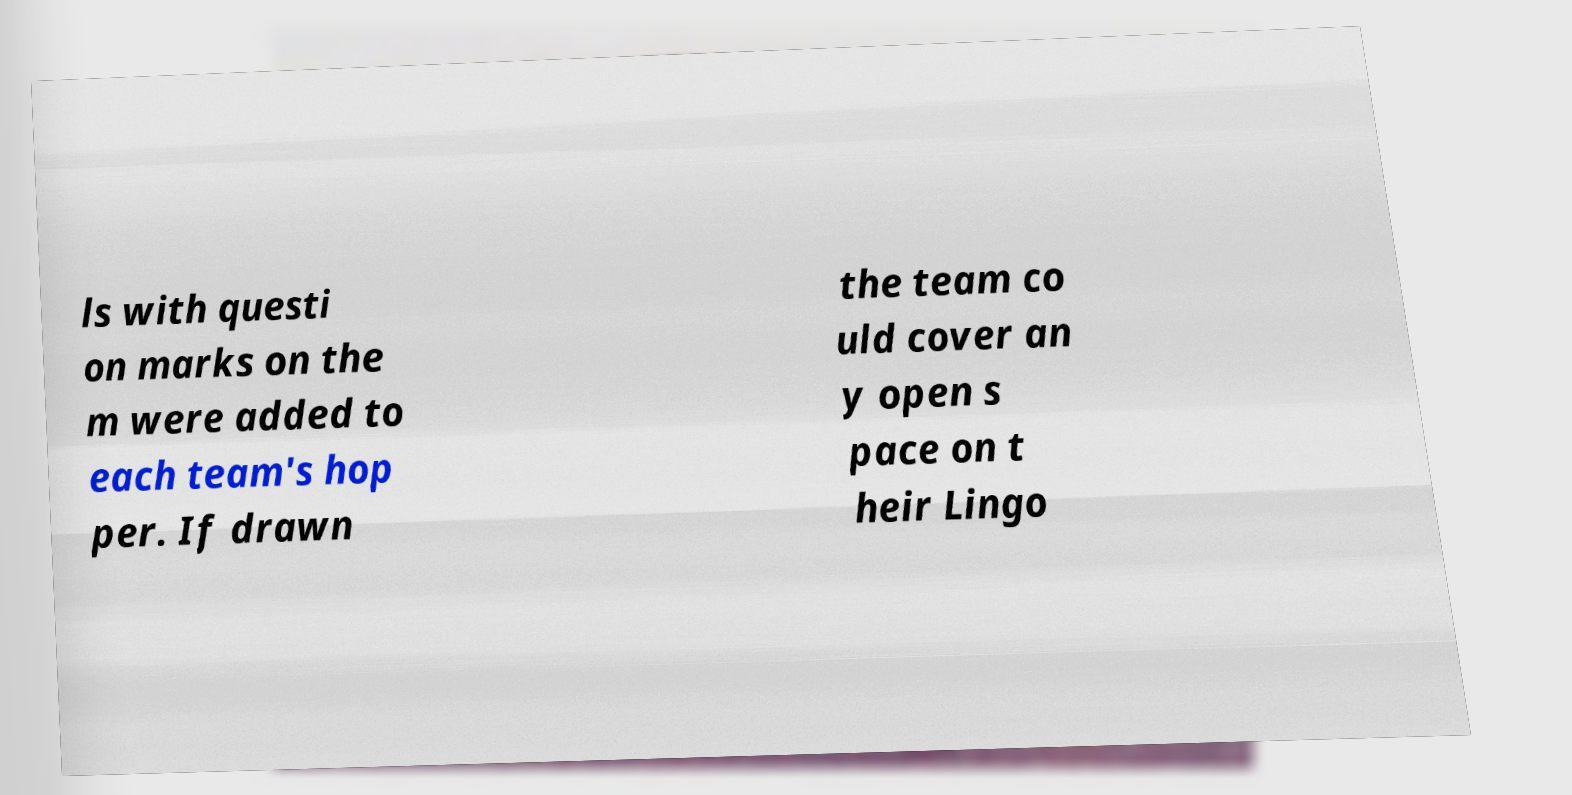Could you assist in decoding the text presented in this image and type it out clearly? ls with questi on marks on the m were added to each team's hop per. If drawn the team co uld cover an y open s pace on t heir Lingo 